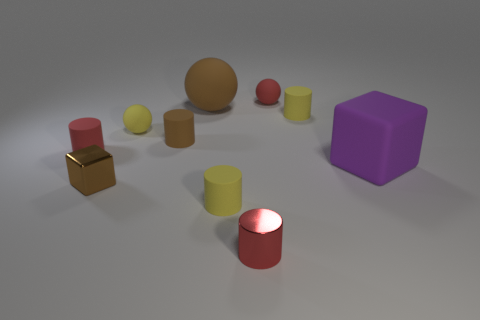Subtract 2 cylinders. How many cylinders are left? 3 Subtract all brown cylinders. How many cylinders are left? 4 Subtract all metallic cylinders. How many cylinders are left? 4 Subtract all blue cylinders. Subtract all green spheres. How many cylinders are left? 5 Subtract all blocks. How many objects are left? 8 Subtract all green metallic blocks. Subtract all brown rubber things. How many objects are left? 8 Add 1 small red metal cylinders. How many small red metal cylinders are left? 2 Add 9 tiny red shiny cylinders. How many tiny red shiny cylinders exist? 10 Subtract 1 yellow balls. How many objects are left? 9 